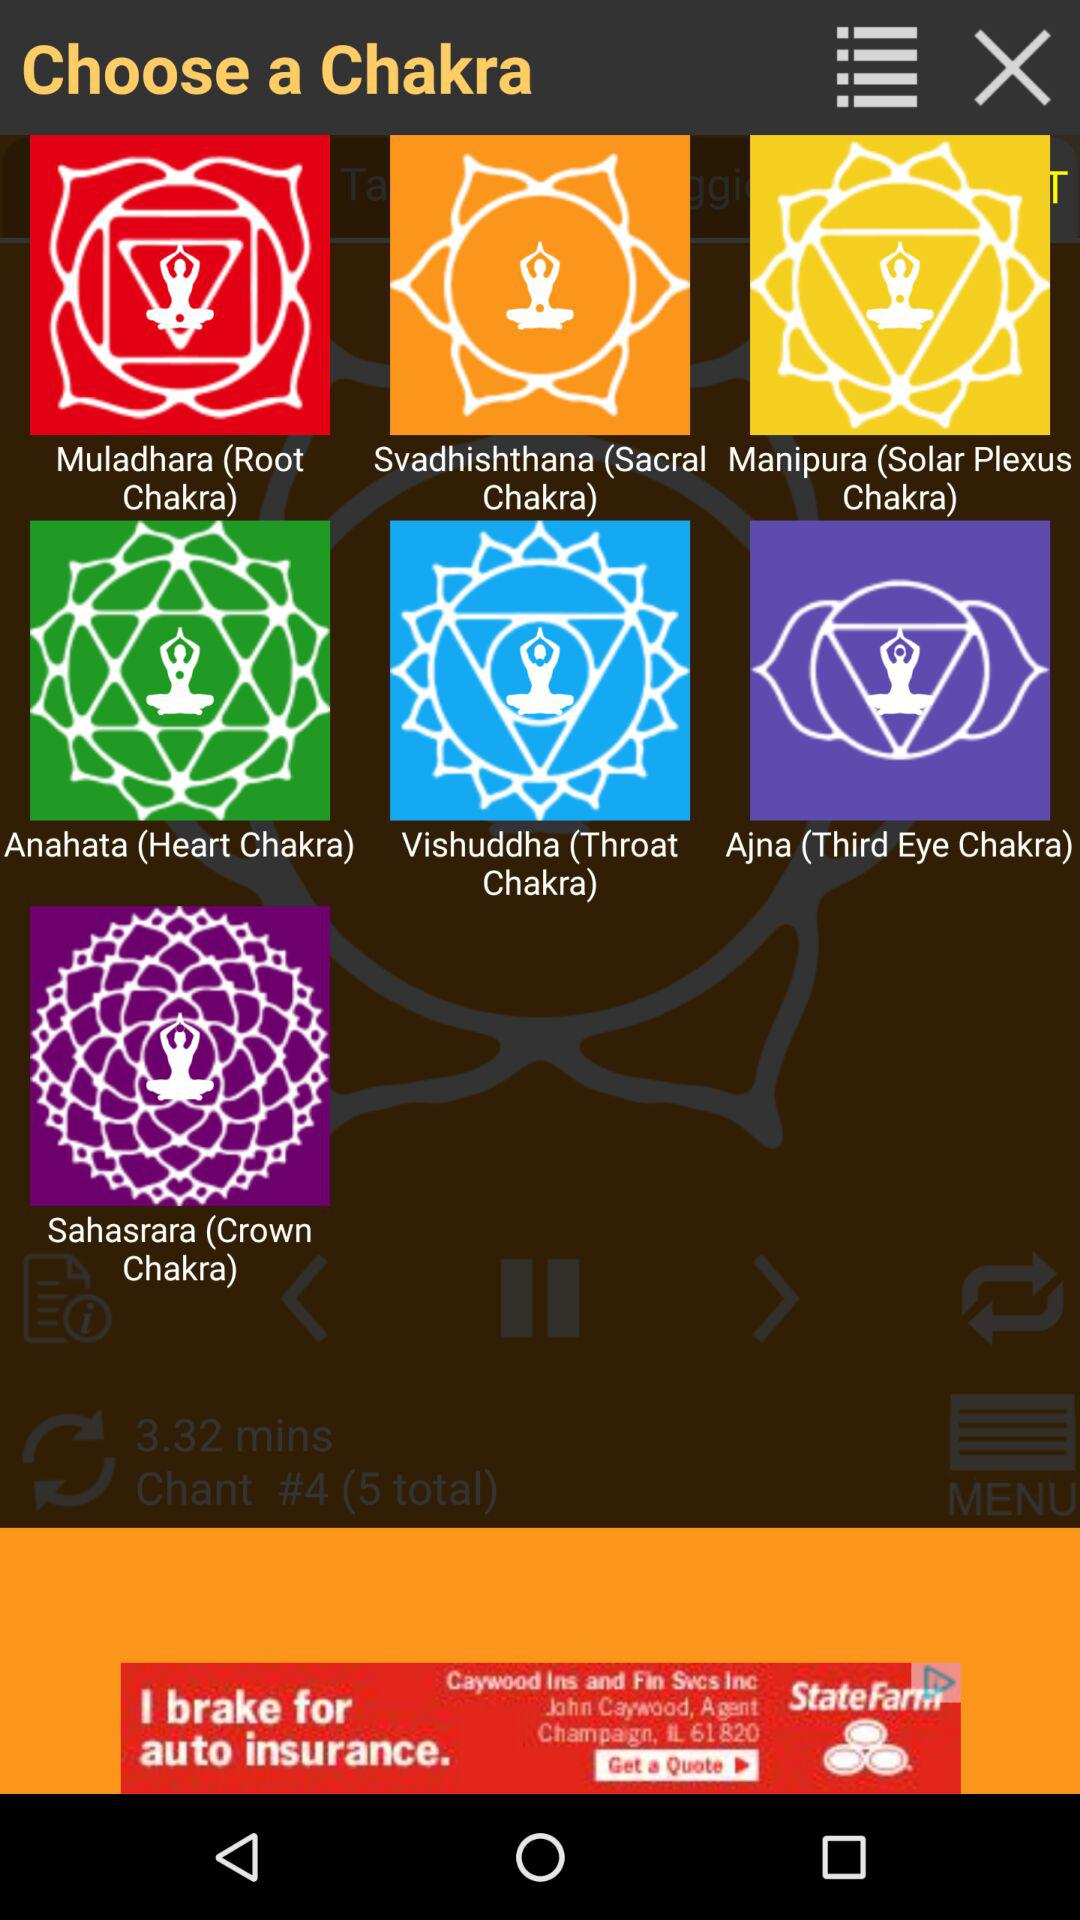Which chakra is selected?
When the provided information is insufficient, respond with <no answer>. <no answer> 